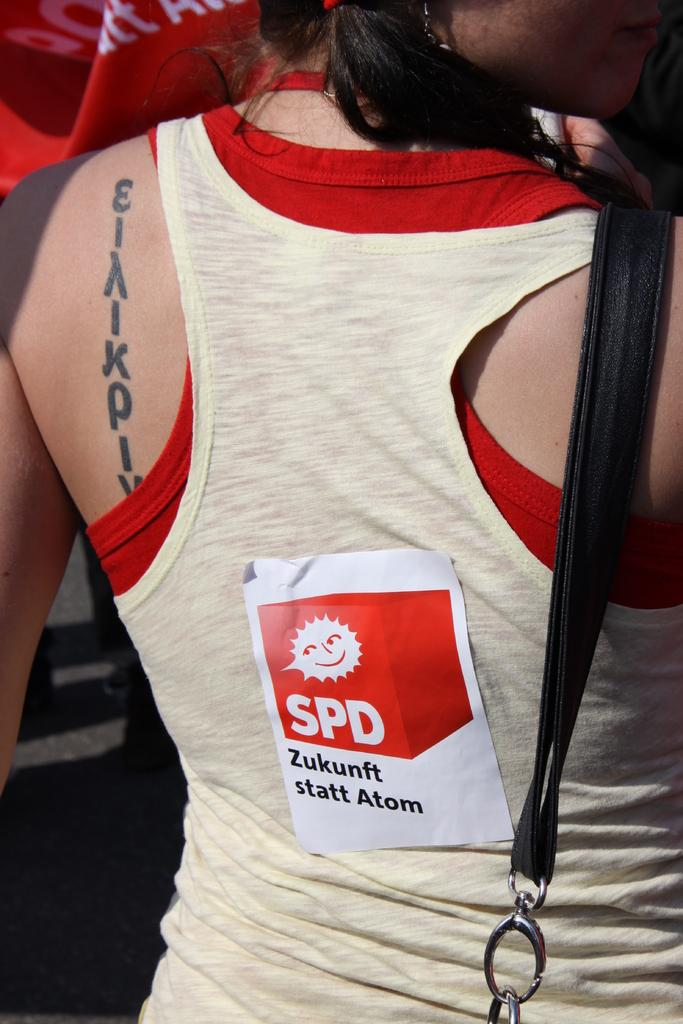<image>
Describe the image concisely. A girl is wearing a tank top that has a sticker for SPD Zukenft statt Atom on it. 